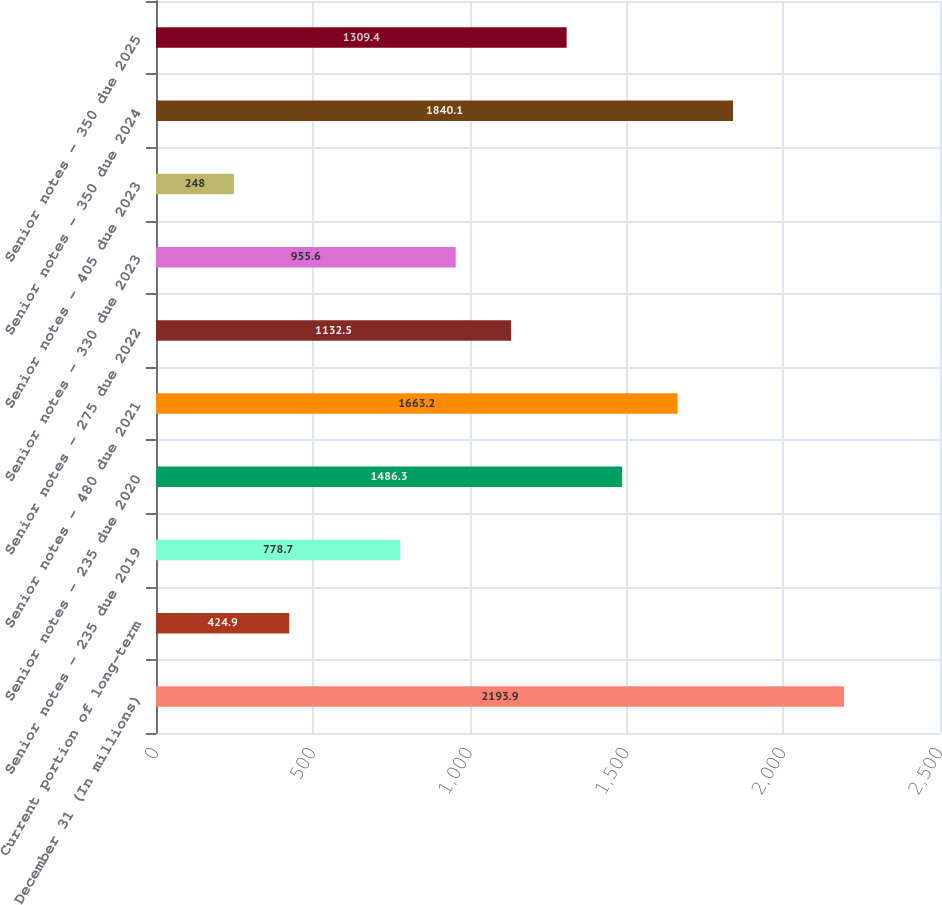Convert chart to OTSL. <chart><loc_0><loc_0><loc_500><loc_500><bar_chart><fcel>December 31 (In millions)<fcel>Current portion of long-term<fcel>Senior notes - 235 due 2019<fcel>Senior notes - 235 due 2020<fcel>Senior notes - 480 due 2021<fcel>Senior notes - 275 due 2022<fcel>Senior notes - 330 due 2023<fcel>Senior notes - 405 due 2023<fcel>Senior notes - 350 due 2024<fcel>Senior notes - 350 due 2025<nl><fcel>2193.9<fcel>424.9<fcel>778.7<fcel>1486.3<fcel>1663.2<fcel>1132.5<fcel>955.6<fcel>248<fcel>1840.1<fcel>1309.4<nl></chart> 